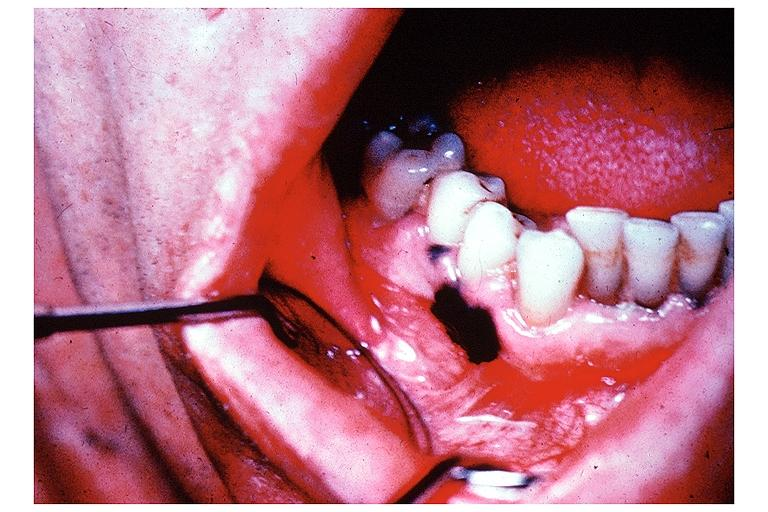does fibrinous peritonitis show melanoma?
Answer the question using a single word or phrase. No 